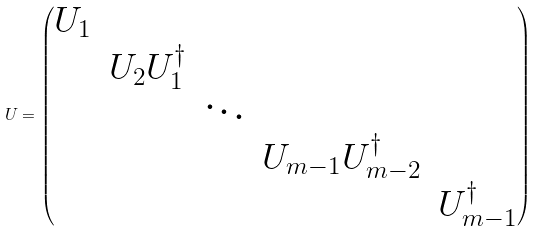<formula> <loc_0><loc_0><loc_500><loc_500>{ U } = \begin{pmatrix} U _ { 1 } & & & & \\ & U _ { 2 } U _ { 1 } ^ { \dagger } & & & \\ & & \ddots & & \\ & & & U _ { m - 1 } U _ { m - 2 } ^ { \dagger } & \\ & & & & U _ { m - 1 } ^ { \dagger } \end{pmatrix}</formula> 